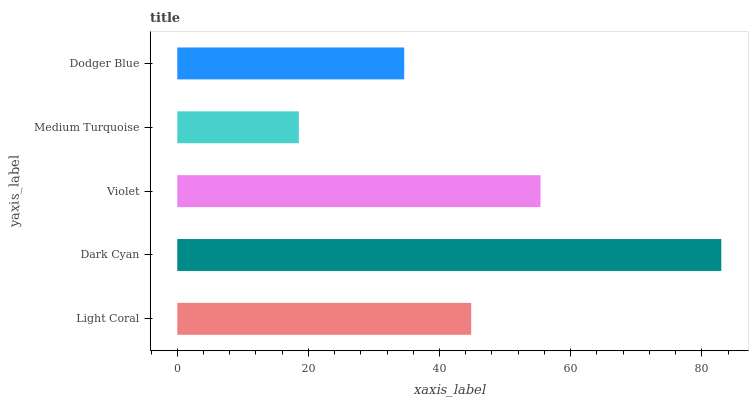Is Medium Turquoise the minimum?
Answer yes or no. Yes. Is Dark Cyan the maximum?
Answer yes or no. Yes. Is Violet the minimum?
Answer yes or no. No. Is Violet the maximum?
Answer yes or no. No. Is Dark Cyan greater than Violet?
Answer yes or no. Yes. Is Violet less than Dark Cyan?
Answer yes or no. Yes. Is Violet greater than Dark Cyan?
Answer yes or no. No. Is Dark Cyan less than Violet?
Answer yes or no. No. Is Light Coral the high median?
Answer yes or no. Yes. Is Light Coral the low median?
Answer yes or no. Yes. Is Dodger Blue the high median?
Answer yes or no. No. Is Medium Turquoise the low median?
Answer yes or no. No. 